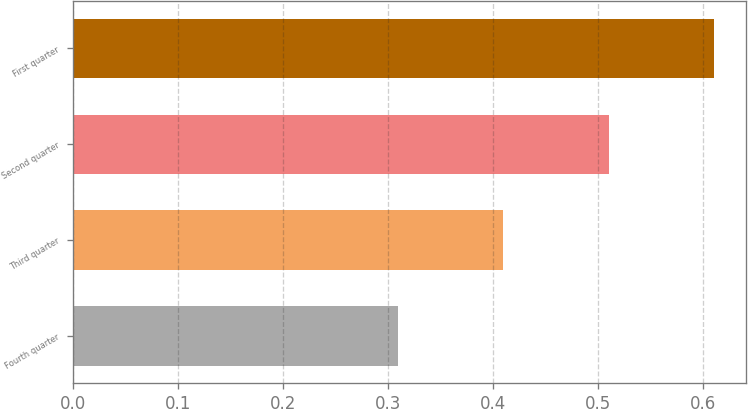Convert chart to OTSL. <chart><loc_0><loc_0><loc_500><loc_500><bar_chart><fcel>Fourth quarter<fcel>Third quarter<fcel>Second quarter<fcel>First quarter<nl><fcel>0.31<fcel>0.41<fcel>0.51<fcel>0.61<nl></chart> 